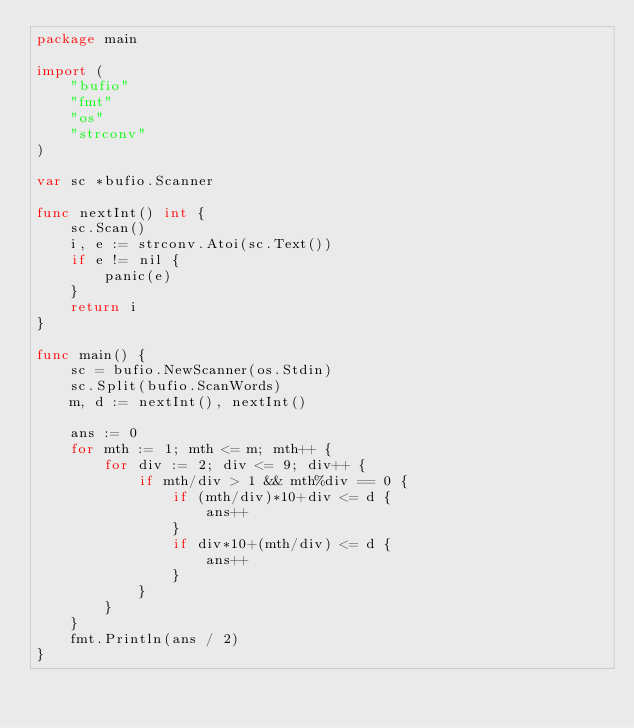<code> <loc_0><loc_0><loc_500><loc_500><_Go_>package main

import (
	"bufio"
	"fmt"
	"os"
	"strconv"
)

var sc *bufio.Scanner

func nextInt() int {
	sc.Scan()
	i, e := strconv.Atoi(sc.Text())
	if e != nil {
		panic(e)
	}
	return i
}

func main() {
	sc = bufio.NewScanner(os.Stdin)
	sc.Split(bufio.ScanWords)
	m, d := nextInt(), nextInt()

	ans := 0
	for mth := 1; mth <= m; mth++ {
		for div := 2; div <= 9; div++ {
			if mth/div > 1 && mth%div == 0 {
				if (mth/div)*10+div <= d {
					ans++
				}
				if div*10+(mth/div) <= d {
					ans++
				}
			}
		}
	}
	fmt.Println(ans / 2)
}
</code> 